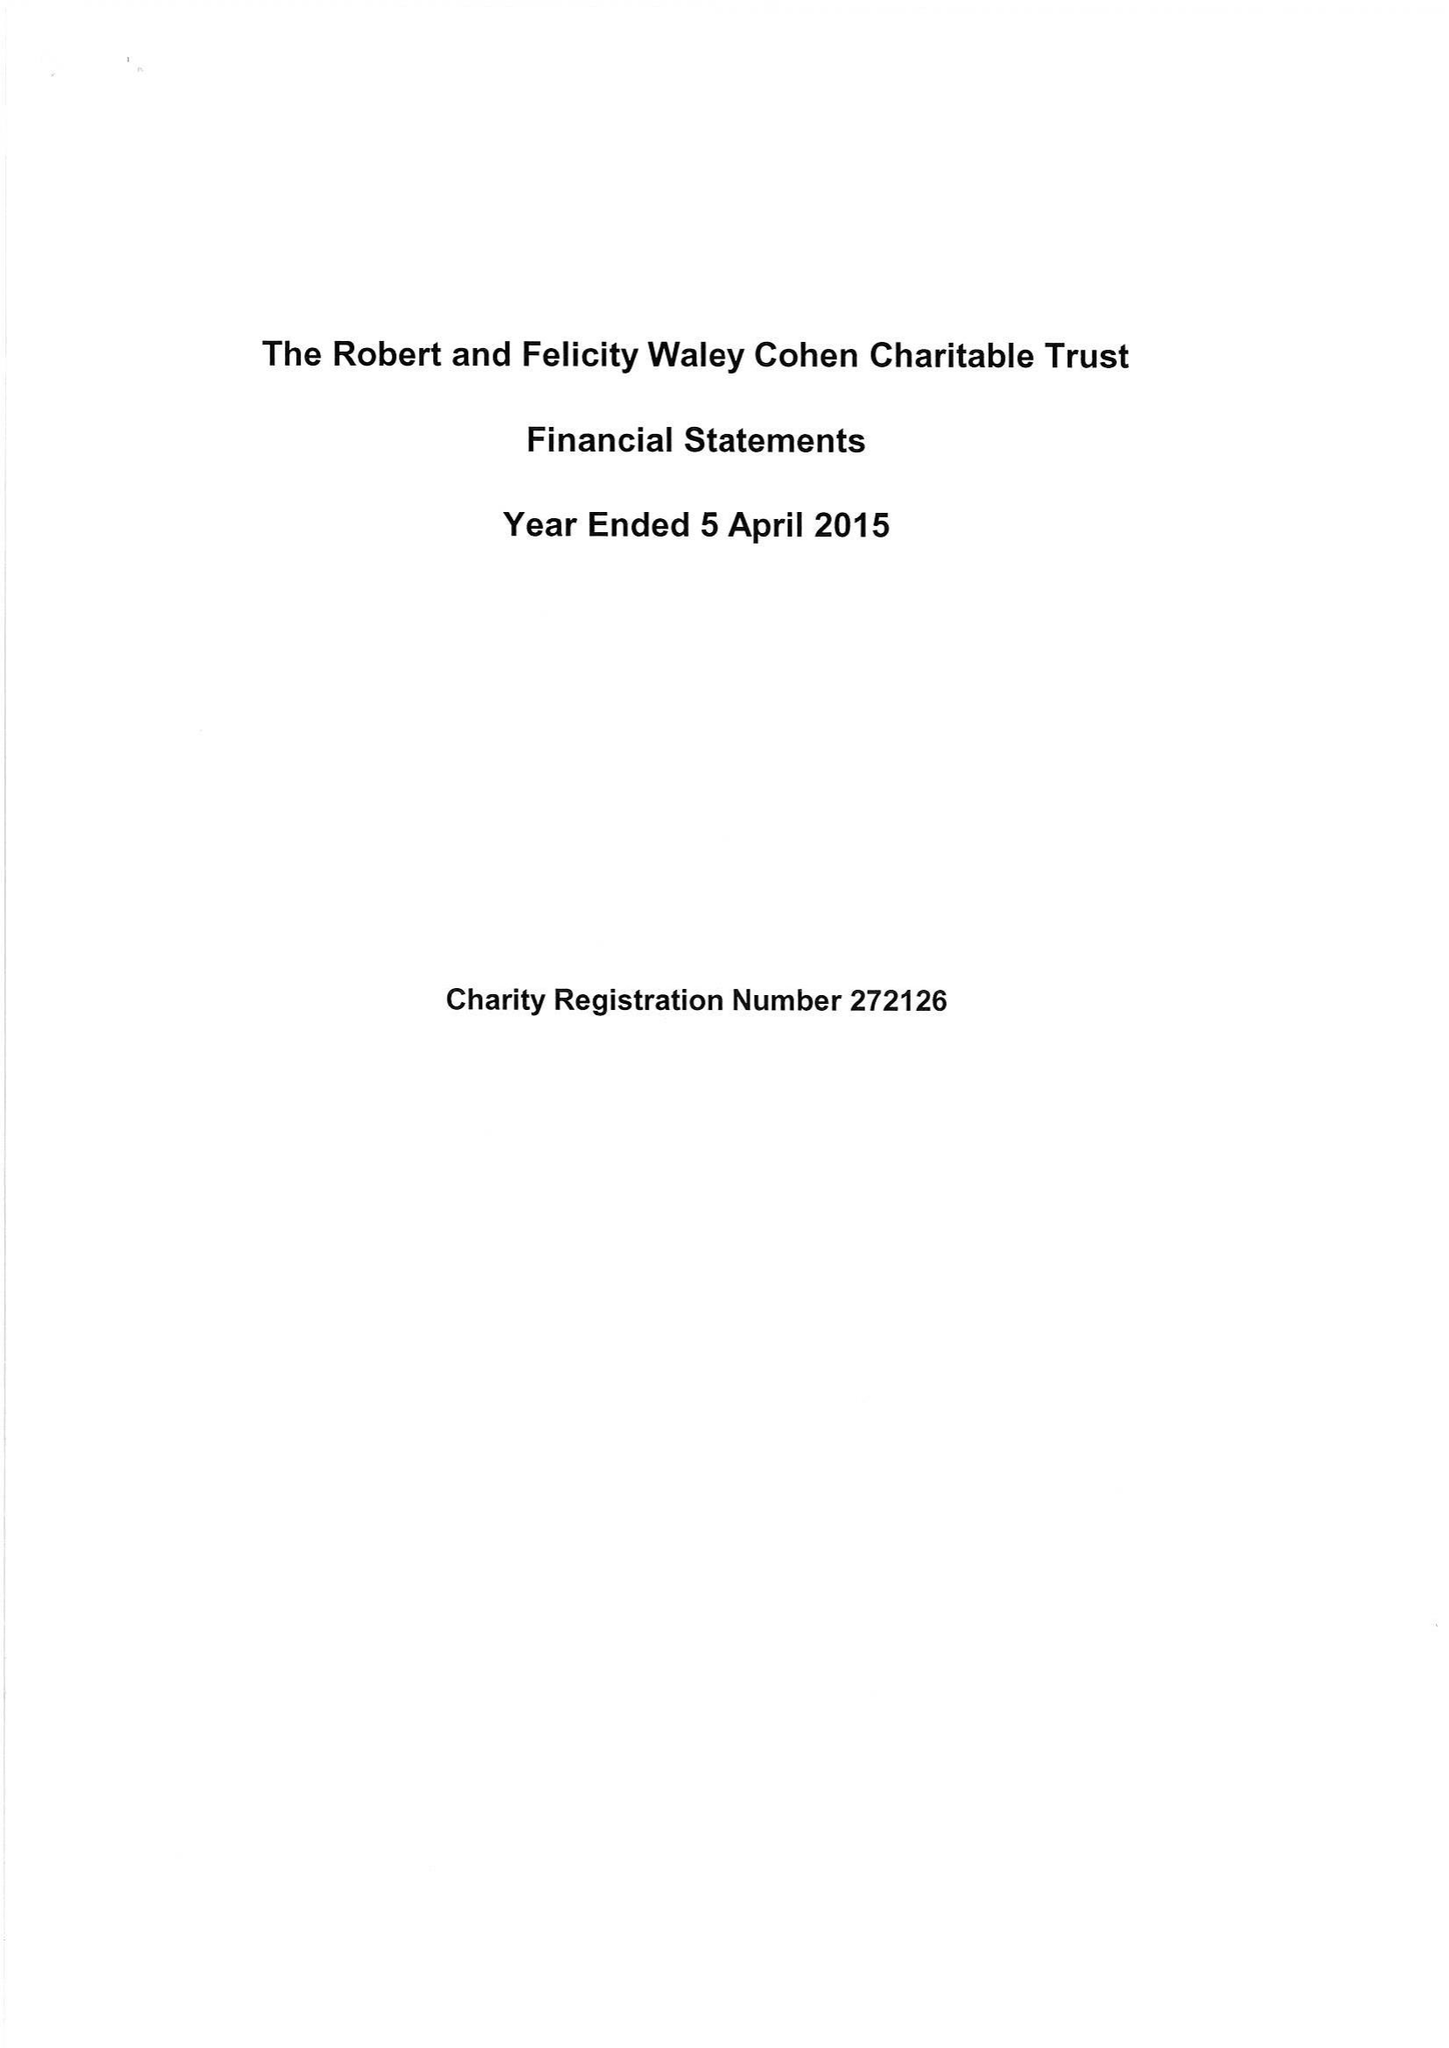What is the value for the spending_annually_in_british_pounds?
Answer the question using a single word or phrase. 230889.00 